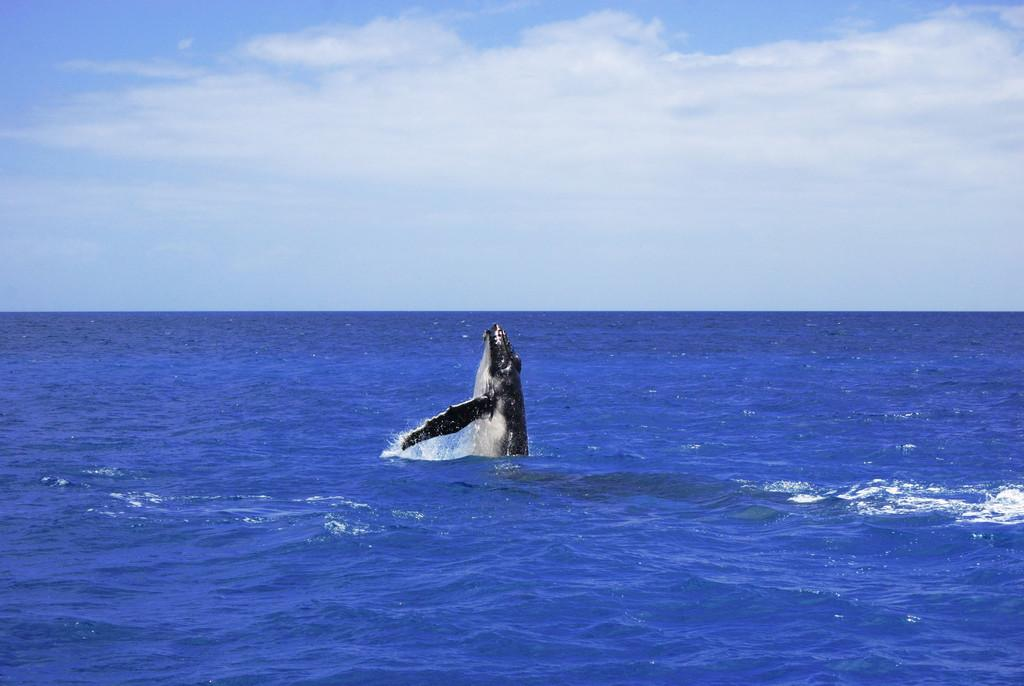What animal is the main subject of the image? There is a whale in the image. What is the whale doing in the image? The whale is jumping. Where is the whale located in the image? The whale is in the ocean. What can be seen above the ocean in the image? The sky is visible in the image, and there are clouds in the sky. Where is the playground located in the image? There is no playground present in the image; it features a whale jumping in the ocean. Can you tell me how many maids are attending to the whale in the image? There are no maids present in the image; it only shows a whale jumping in the ocean. 